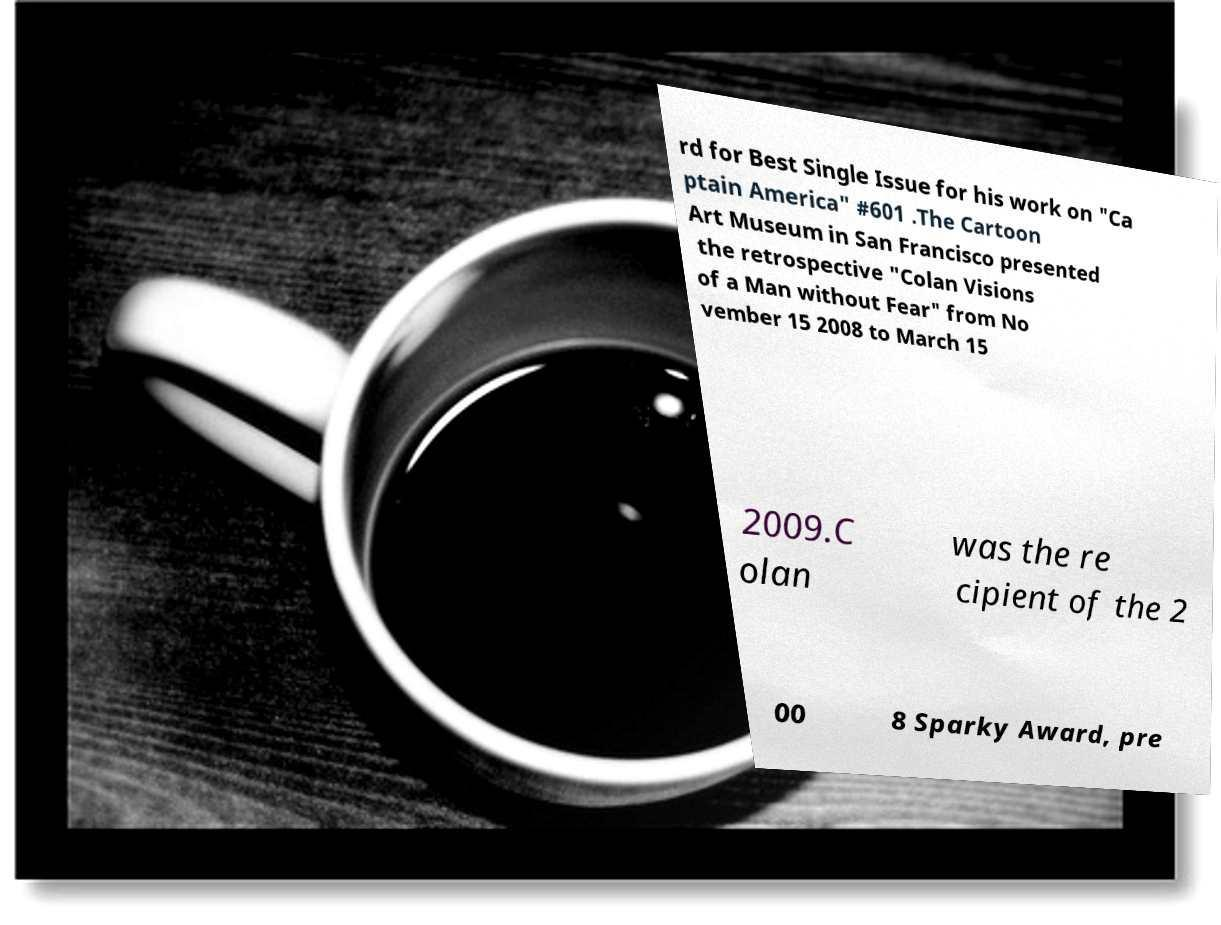Could you extract and type out the text from this image? rd for Best Single Issue for his work on "Ca ptain America" #601 .The Cartoon Art Museum in San Francisco presented the retrospective "Colan Visions of a Man without Fear" from No vember 15 2008 to March 15 2009.C olan was the re cipient of the 2 00 8 Sparky Award, pre 